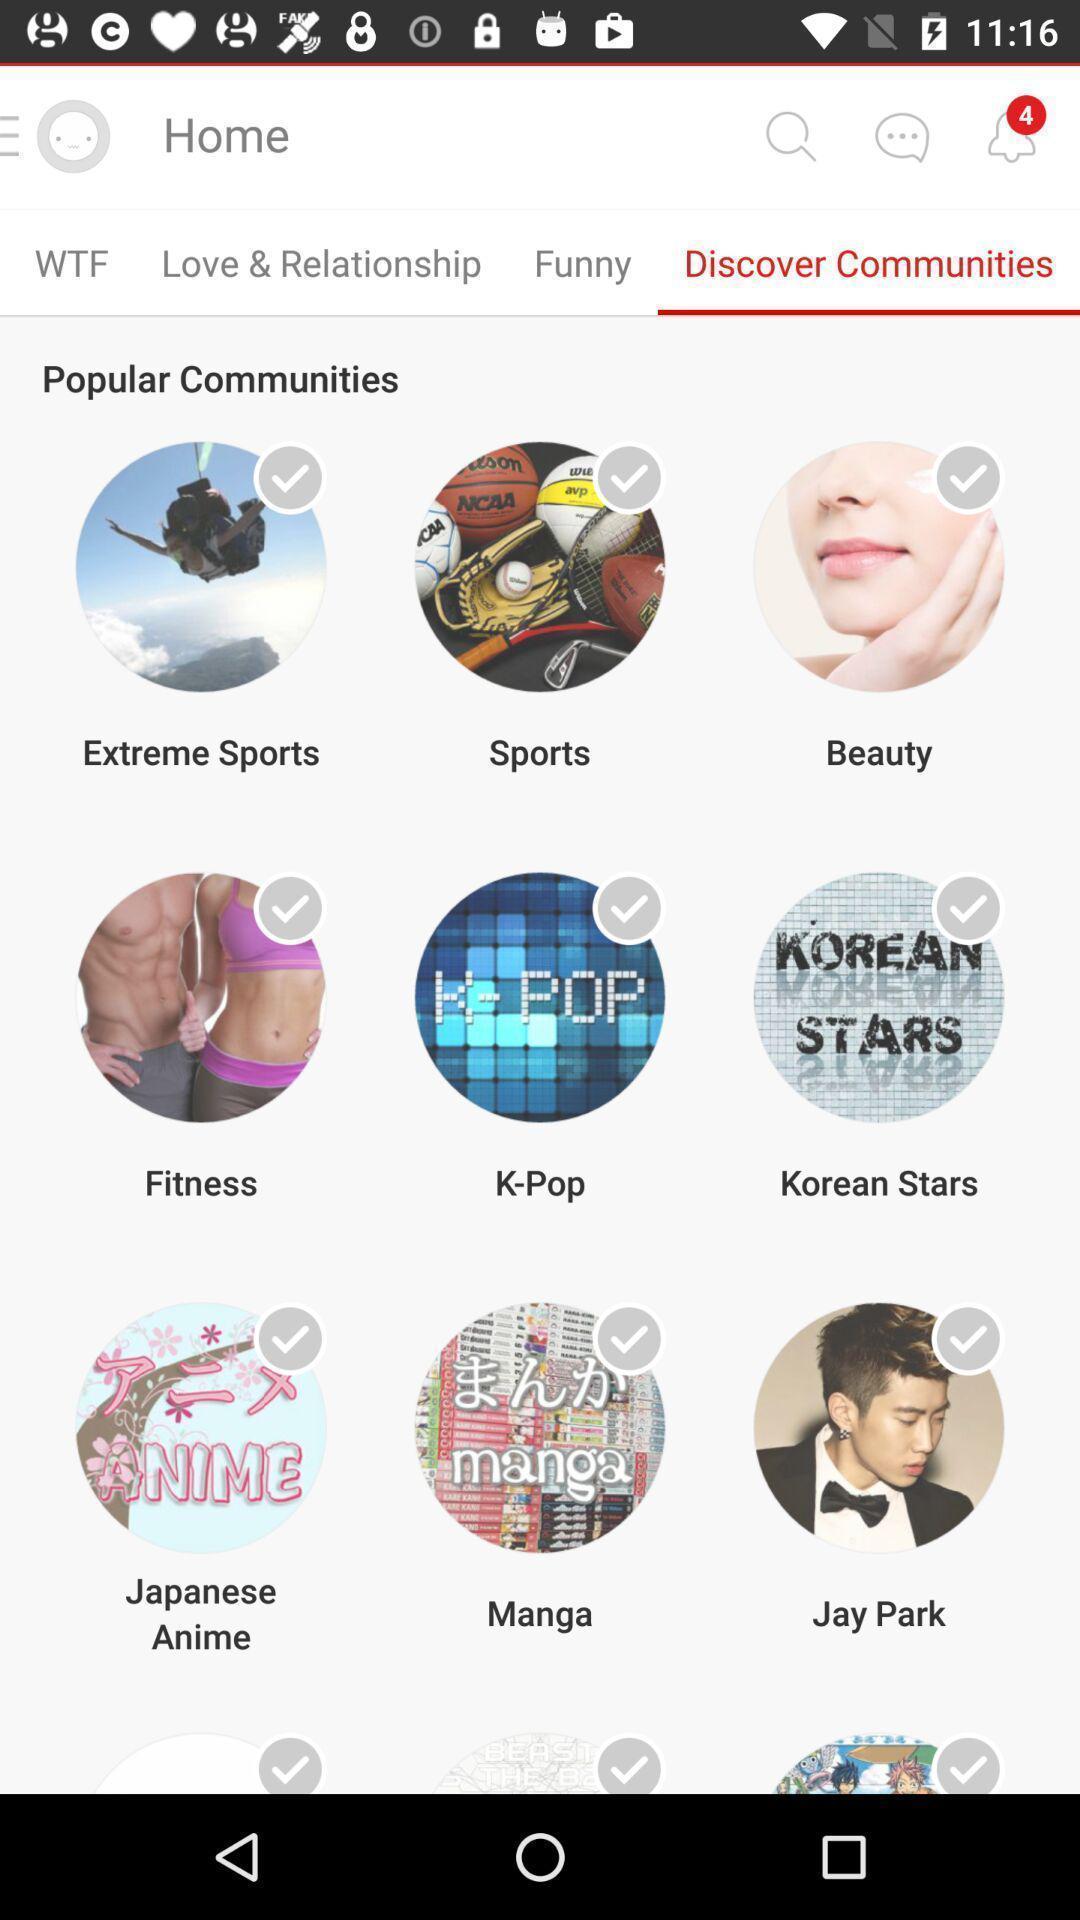Describe this image in words. Window displaying list of different communities. 